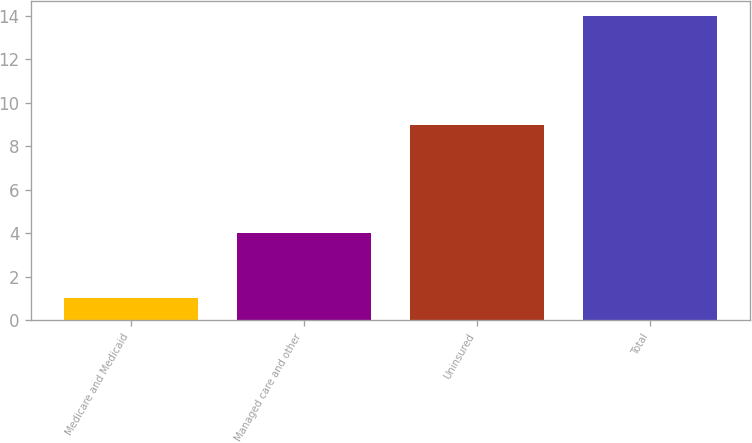Convert chart to OTSL. <chart><loc_0><loc_0><loc_500><loc_500><bar_chart><fcel>Medicare and Medicaid<fcel>Managed care and other<fcel>Uninsured<fcel>Total<nl><fcel>1<fcel>4<fcel>9<fcel>14<nl></chart> 